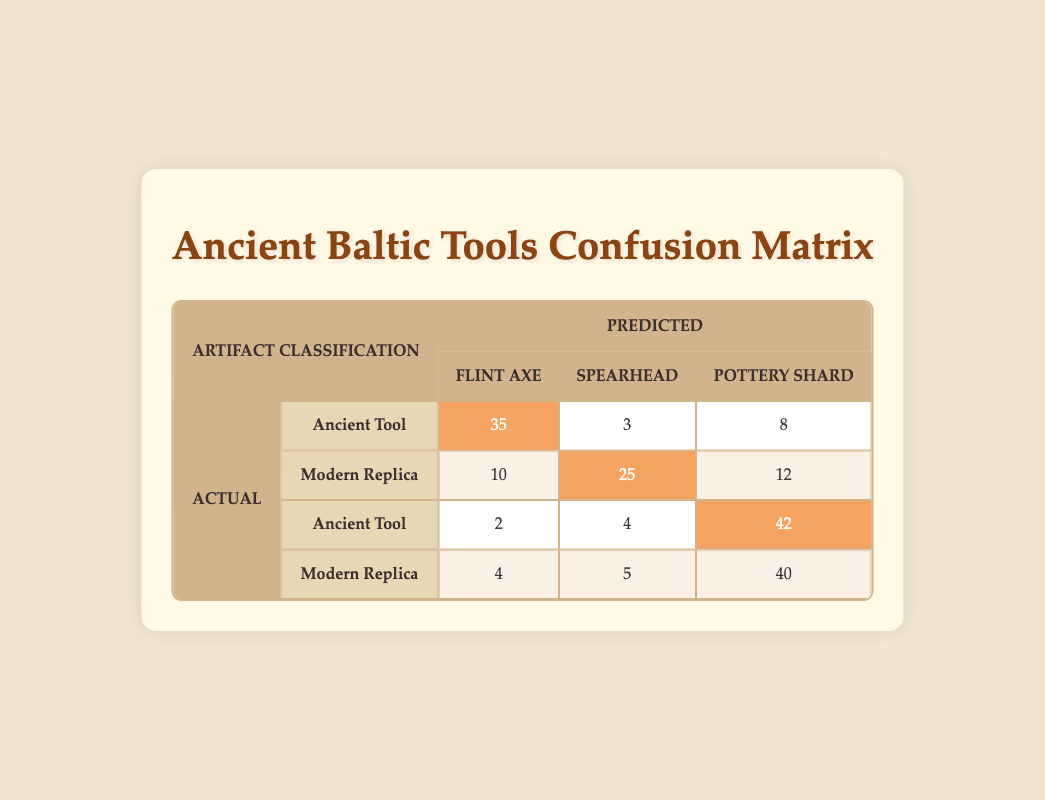What is the number of True Positives for Pottery Shard classified as Ancient Tool? The table shows that the number of True Positives for Pottery Shard classified as Ancient Tool is in the corresponding row and column under True Positive for Ancient Tool. It is 42.
Answer: 42 What is the total number of False Positives for Flint Axe? To find the total False Positives for Flint Axe, we sum the values from both the Ancient Tool and Modern Replica categories. For Ancient Tool, it is 5, and for Modern Replica, it is 10. So, 5 + 10 = 15.
Answer: 15 Is the number of True Negatives for Modern Replica Pottery Shard greater than for Ancient Tool? The True Negatives for Modern Replica Pottery Shard is 50, while for Ancient Tool it is 48. Since 50 is greater than 48, the answer is yes.
Answer: Yes What is the total number of True Positives for all categories? We need to sum the True Positives for all three artifact types under both Ancient Tool and Modern Replica categories. For Ancient Tool: 35 (Flint Axe) + 28 (Spearhead) + 42 (Pottery Shard) = 105. For Modern Replica: 30 + 25 + 40 = 95. Total = 105 + 95 = 200.
Answer: 200 How many False Negatives are there for Spearhead classified as Modern Replica? The table indicates that there are 5 False Negatives for Spearhead classified as Modern Replica, which can be found in the relevant column and row.
Answer: 5 What is the difference between the True Positives for Flint Axe and Spearhead classified as Ancient Tool? The True Positive for Flint Axe as Ancient Tool is 35, and for Spearhead, it is 28. To find the difference, we subtract: 35 - 28 = 7.
Answer: 7 What is the cumulative amount of False Positives for both types of artifacts? To find the cumulative False Positives, we need to sum the values of False Positives in both categories. For Ancient Tool: 5 (Flint Axe) + 3 (Spearhead) + 8 (Pottery Shard) = 16. For Modern Replica: 10 + 10 + 12 = 32. The cumulative amount is 16 + 32 = 48.
Answer: 48 Is there a higher count of True Negatives for Ancient Tools compared to Modern Replicas? The count for True Negatives for Ancient Tool is 50 (Flint Axe), 42 (Spearhead), and 48 (Pottery Shard), totaling 140. For Modern Replica: 45 + 40 + 50 = 135. Since 140 is greater than 135, the answer is yes.
Answer: Yes What is the average number of False Negatives across all artifact categories? The False Negatives total for Ancient Tool: 2 (Flint Axe) + 4 (Spearhead) + 5 (Pottery Shard) = 11. For Modern Replica: 4 + 5 + 6 = 15. The total False Negatives are 11 + 15 = 26, and there are 6 categories of artifacts (3 for each type). Thus, the average is 26 / 6 = approximately 4.33.
Answer: 4.33 